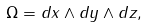Convert formula to latex. <formula><loc_0><loc_0><loc_500><loc_500>\Omega = d x \wedge d y \wedge d z ,</formula> 